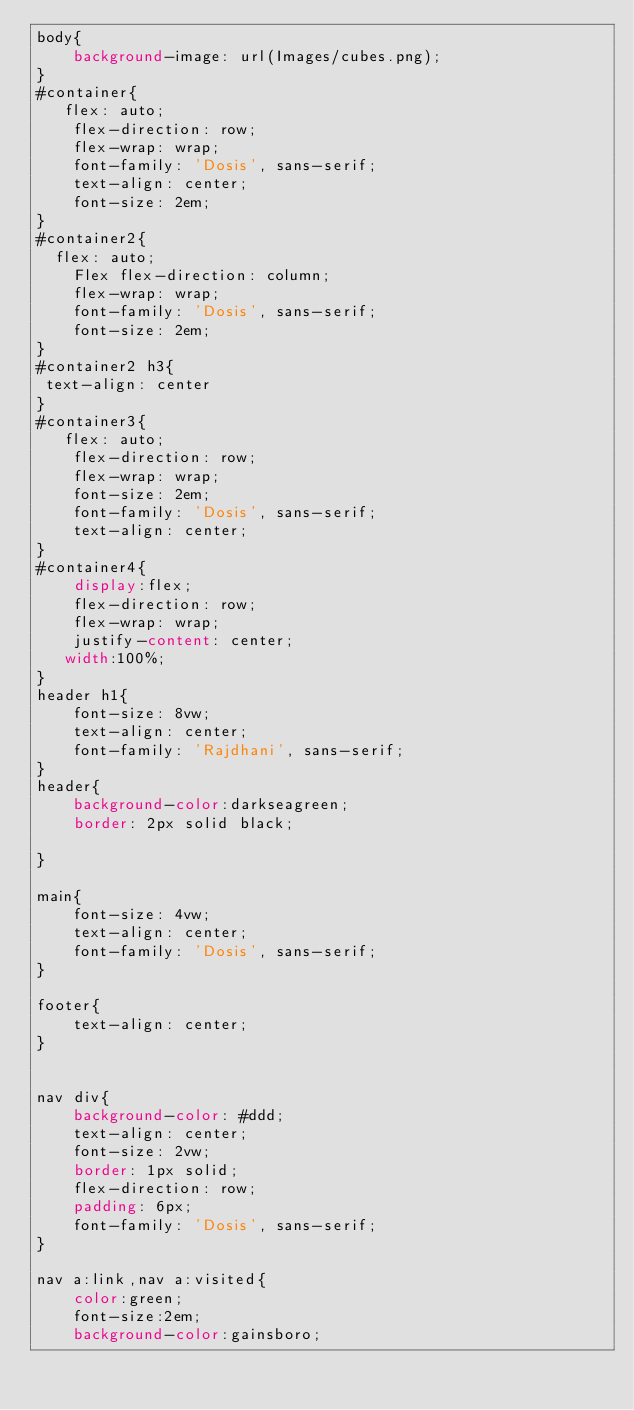<code> <loc_0><loc_0><loc_500><loc_500><_CSS_>body{
    background-image: url(Images/cubes.png);
}
#container{
   flex: auto;
    flex-direction: row;
    flex-wrap: wrap;
    font-family: 'Dosis', sans-serif;
    text-align: center;
    font-size: 2em;
}
#container2{
  flex: auto;
    Flex flex-direction: column;
    flex-wrap: wrap;
    font-family: 'Dosis', sans-serif;
    font-size: 2em;
}
#container2 h3{
 text-align: center
}
#container3{
   flex: auto;
    flex-direction: row;
    flex-wrap: wrap;
    font-size: 2em;
    font-family: 'Dosis', sans-serif;
    text-align: center;
}
#container4{
    display:flex;
    flex-direction: row;
    flex-wrap: wrap;
    justify-content: center;
   width:100%;
}
header h1{
    font-size: 8vw;
    text-align: center;
    font-family: 'Rajdhani', sans-serif;
}
header{
    background-color:darkseagreen;
    border: 2px solid black;

}

main{
    font-size: 4vw;
    text-align: center;
    font-family: 'Dosis', sans-serif;
}

footer{
    text-align: center;
}


nav div{
    background-color: #ddd;
    text-align: center;
    font-size: 2vw;
    border: 1px solid;
    flex-direction: row;
    padding: 6px;
    font-family: 'Dosis', sans-serif;
}

nav a:link,nav a:visited{
    color:green;
    font-size:2em;
    background-color:gainsboro;</code> 